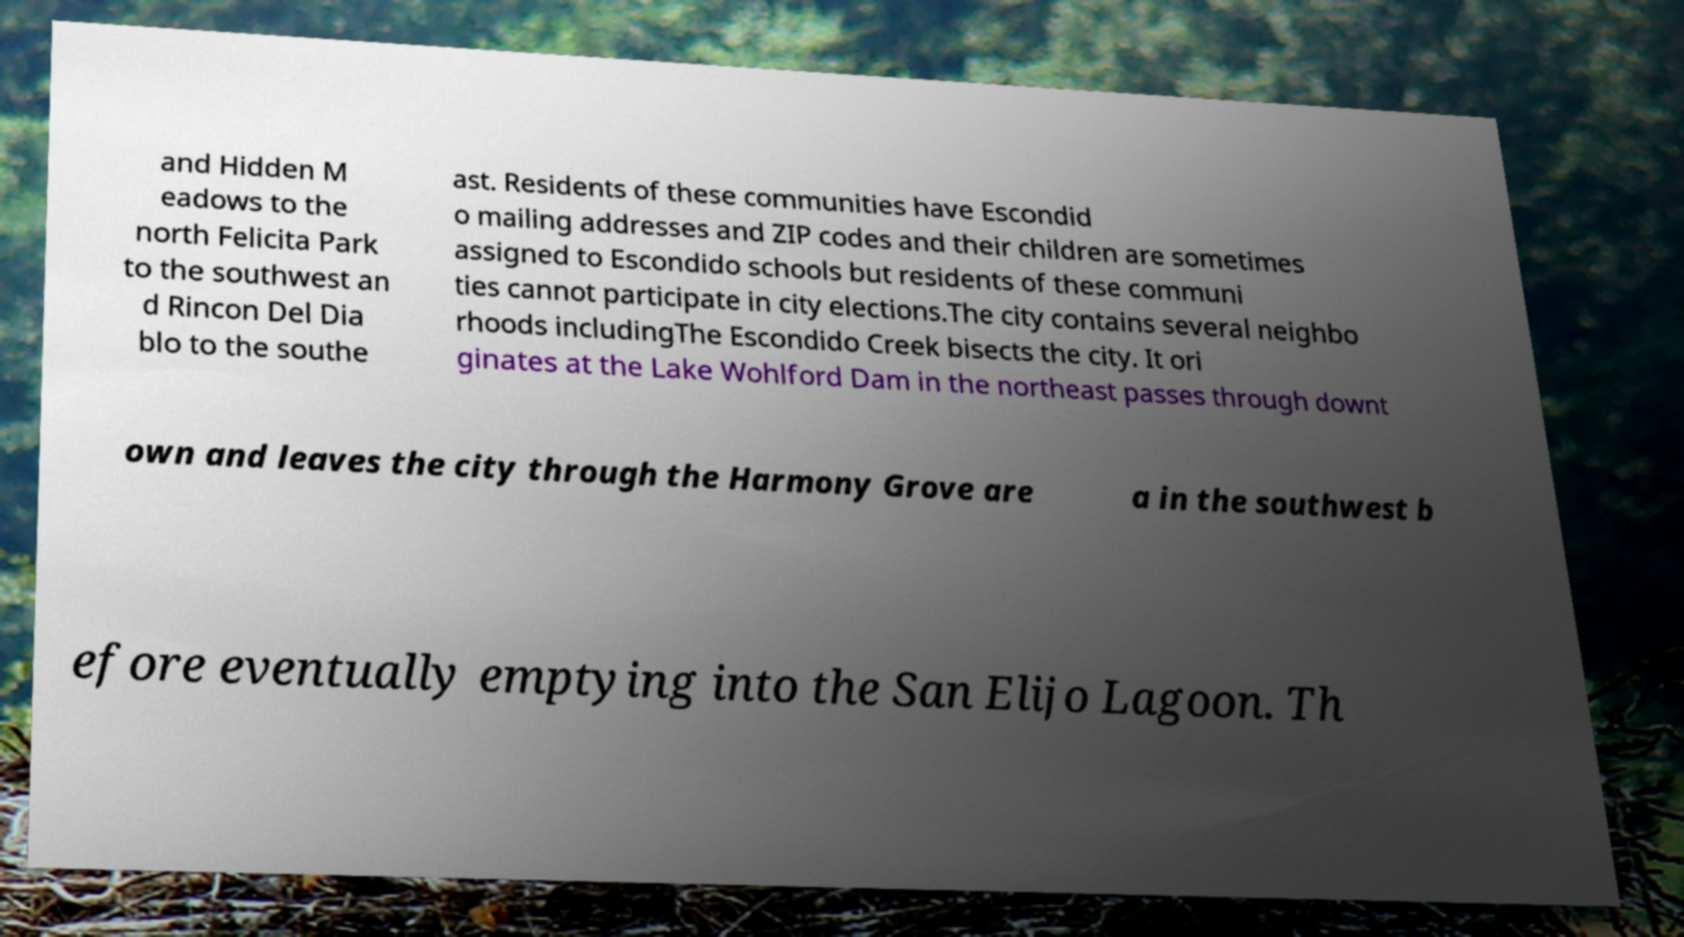What messages or text are displayed in this image? I need them in a readable, typed format. and Hidden M eadows to the north Felicita Park to the southwest an d Rincon Del Dia blo to the southe ast. Residents of these communities have Escondid o mailing addresses and ZIP codes and their children are sometimes assigned to Escondido schools but residents of these communi ties cannot participate in city elections.The city contains several neighbo rhoods includingThe Escondido Creek bisects the city. It ori ginates at the Lake Wohlford Dam in the northeast passes through downt own and leaves the city through the Harmony Grove are a in the southwest b efore eventually emptying into the San Elijo Lagoon. Th 